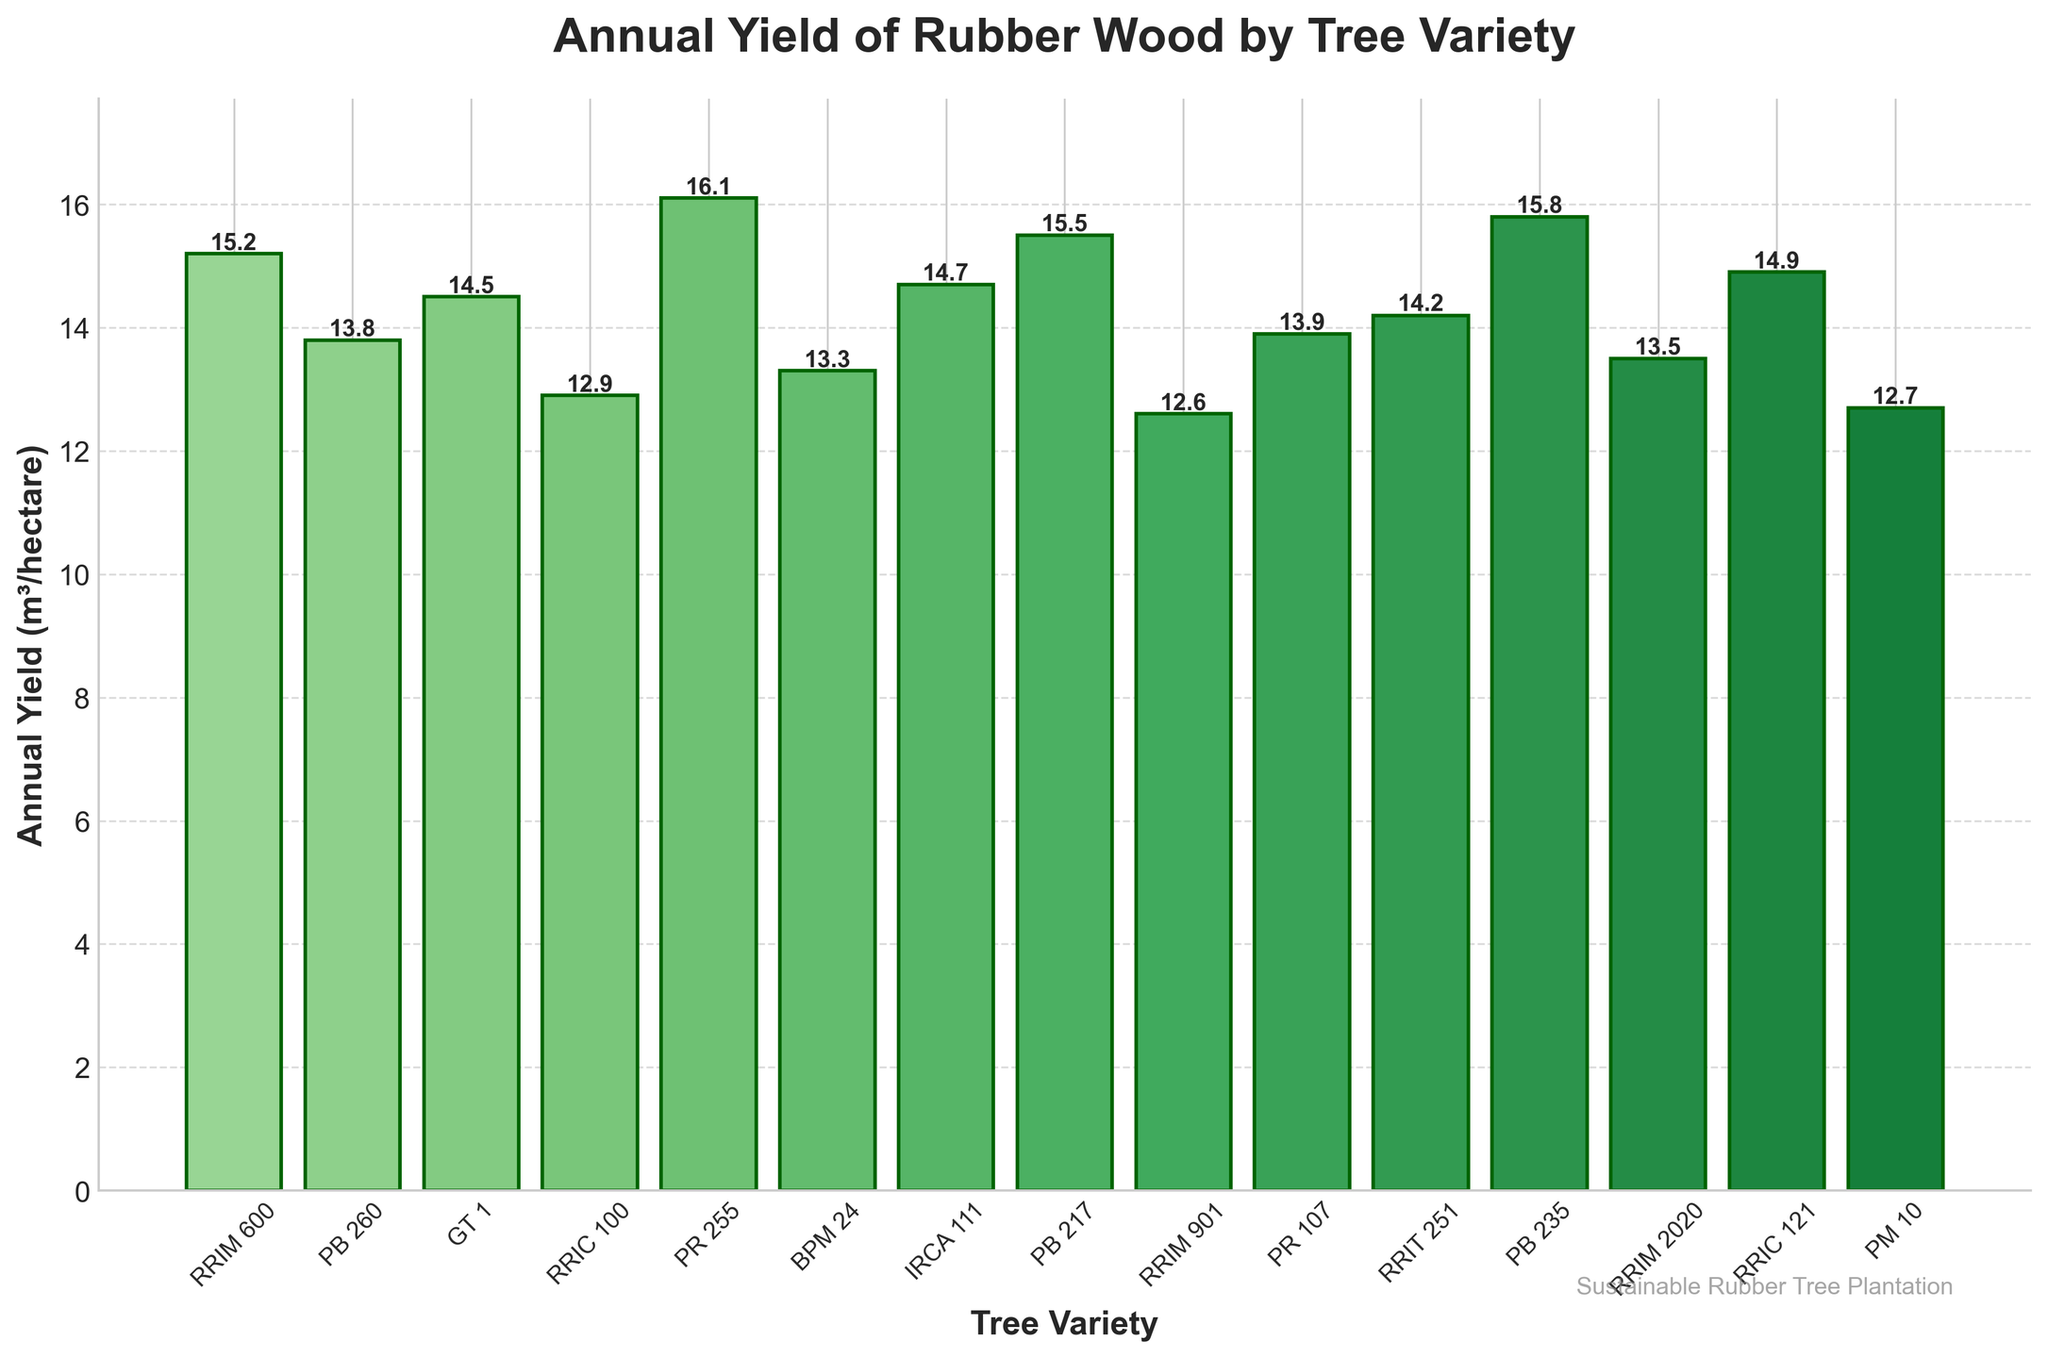What is the variety with the highest annual yield of rubber wood? Look for the bar that has the greatest height. The height will have a correspondent variety.
Answer: PR 255 Which tree variety has a slightly lower yield than PB 217? Compare the height of the bar for PB 217 with the next highest bar. Identify the label of that bar.
Answer: PB 235 How does the yield of PR 107 compare to BPM 24? Compare the heights of the bars for PR 107 and BPM 24. PR 107 has a yield of 13.9 m³/hectare, while BPM 24 has a yield of 13.3 m³/hectare.
Answer: PR 107 is higher Which tree variety shows the closest yield to 14 m³/hectare? Check the labels and their corresponding heights to see which is closest to 14 m³/hectare. The closest variety is GT 1 at 14.5 m³/hectare.
Answer: GT 1 What is the average yield of the three lowest-yielding tree varieties? Identify the three bars with the smallest heights as RRIC 100 (12.9), PR 107 (13.9), and BPM 24 (13.3). Compute the average: (12.9 + 13.9 + 13.3)/3 ≈ 13.37.
Answer: 13.37 What is the total annual yield for varieties with yields above 15 m³/hectare? Identify bars with heights greater than 15 m³/hectare: RRIM 600 (15.2), PB 217 (15.5), PB 235 (15.8), and PR 255 (16.1). Sum these values: 15.2 + 15.5 + 15.8 + 16.1 = 62.6.
Answer: 62.6 Which variety has the second-highest annual yield? Identify the bar with the second-highest height. The bar with the highest yield is PR 255, and the one just below it is PB 235.
Answer: PB 235 Is the yield of RRIC 121 higher or lower than that of GT 1? Compare the heights of the bars for RRIC 121 and GT 1. RRIC 121 is 14.9 m³/hectare, whereas GT 1 is 14.5 m³/hectare.
Answer: Higher What are the yields of varieties beginning with "RRIM"? Identify the bars corresponding to all the varieties starting with "RRIM": RRIM 600 (15.2), RRIM 901 (12.6), and RRIM 2020 (13.5)
Answer: 15.2, 12.6, 13.5 Does PB 260 have a higher or lower yield than IRCA 111? Compare the heights of the bars for PB 260 and IRCA 111. PB 260 has a yield of 13.8 m³/hectare, and IRCA 111 has 14.7 m³/hectare.
Answer: Lower 